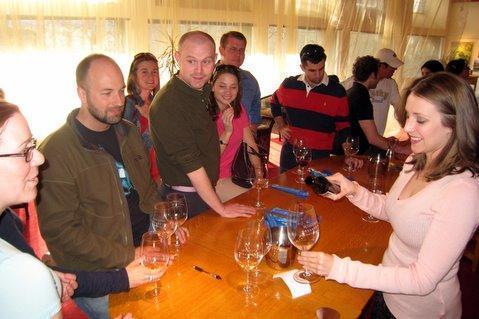What kind of event is this?
Choose the right answer from the provided options to respond to the question.
Options: Graduation ceremony, party, church gathering, funeral. Party. 